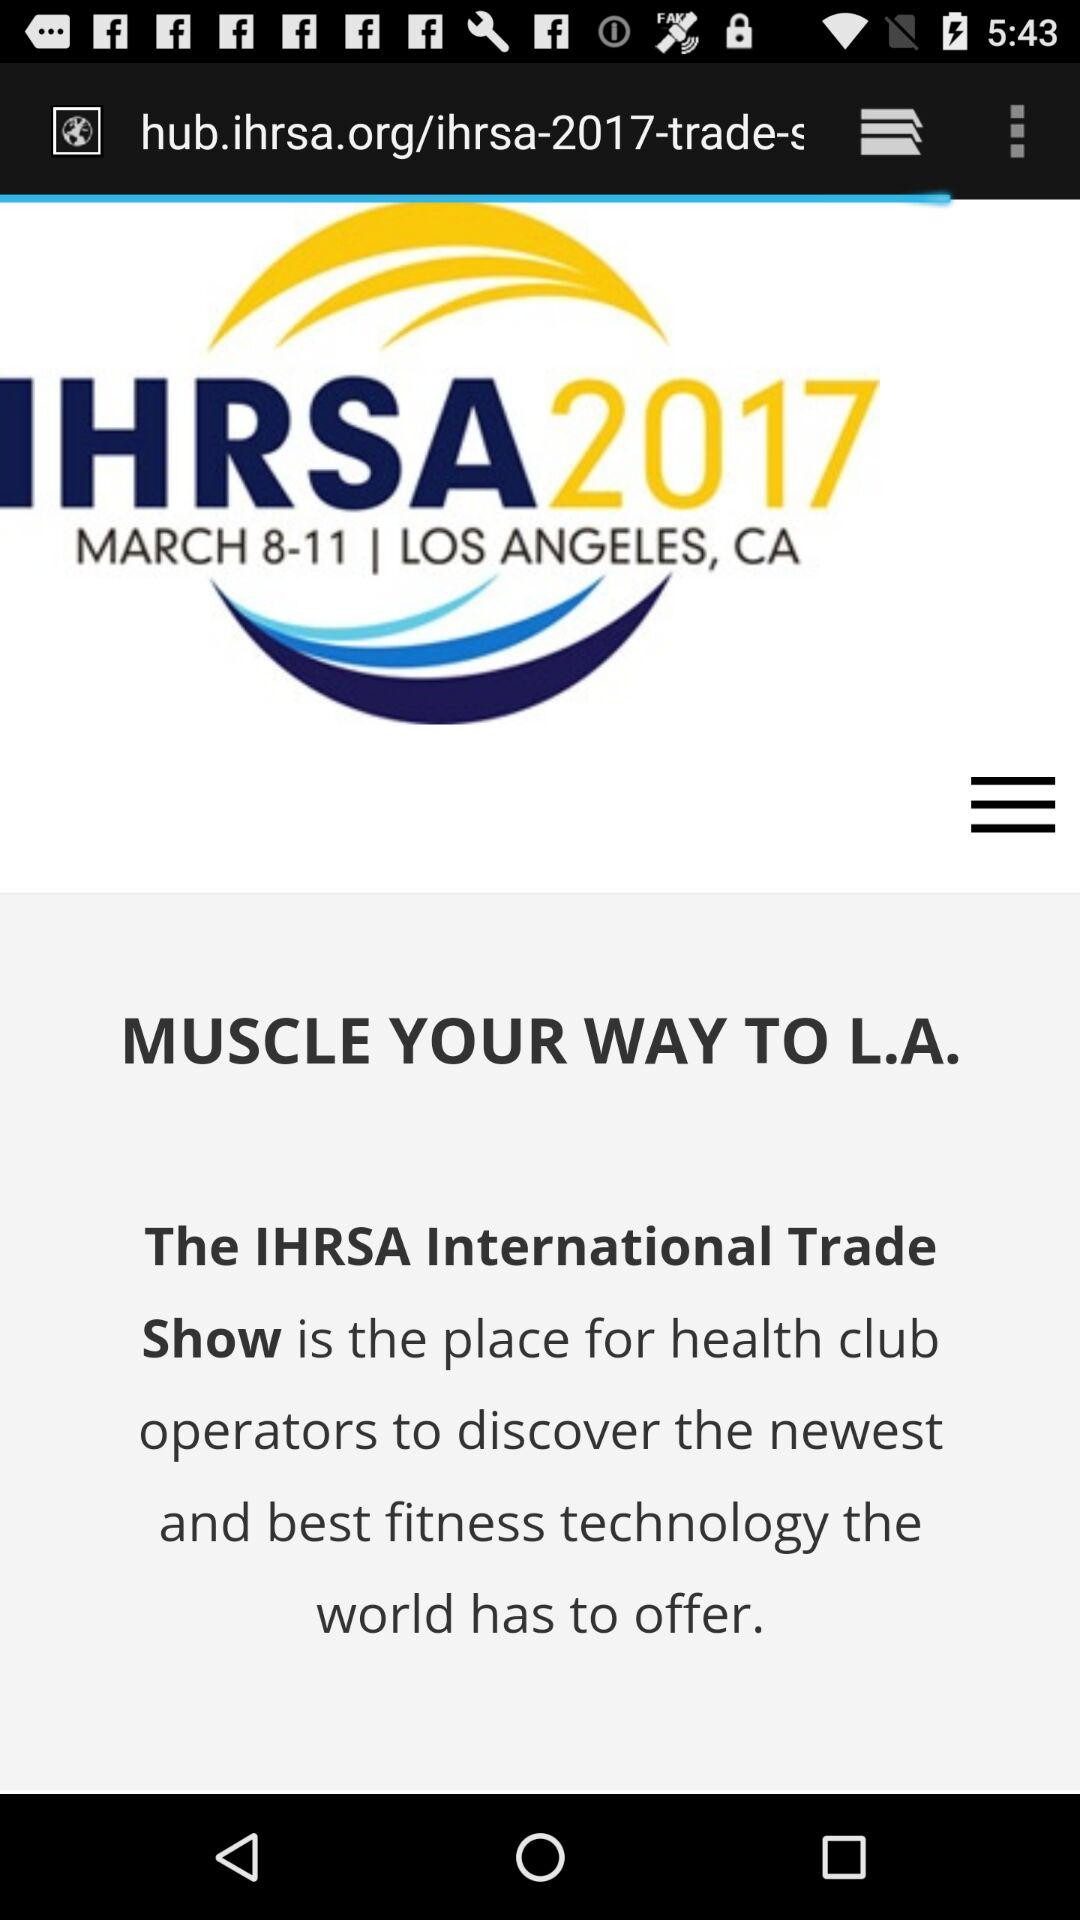In which year was the IHRSA show held? The IHRSA show was held in 2017. 